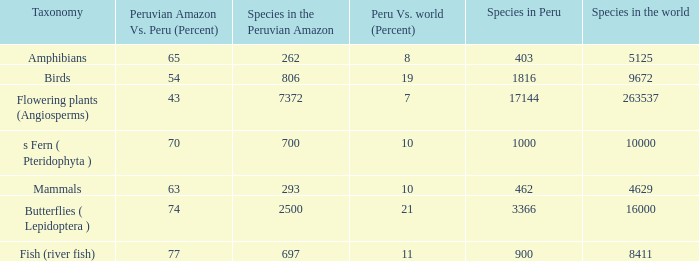What's the minimum species in the peruvian amazon with peru vs. world (percent) value of 7 7372.0. 